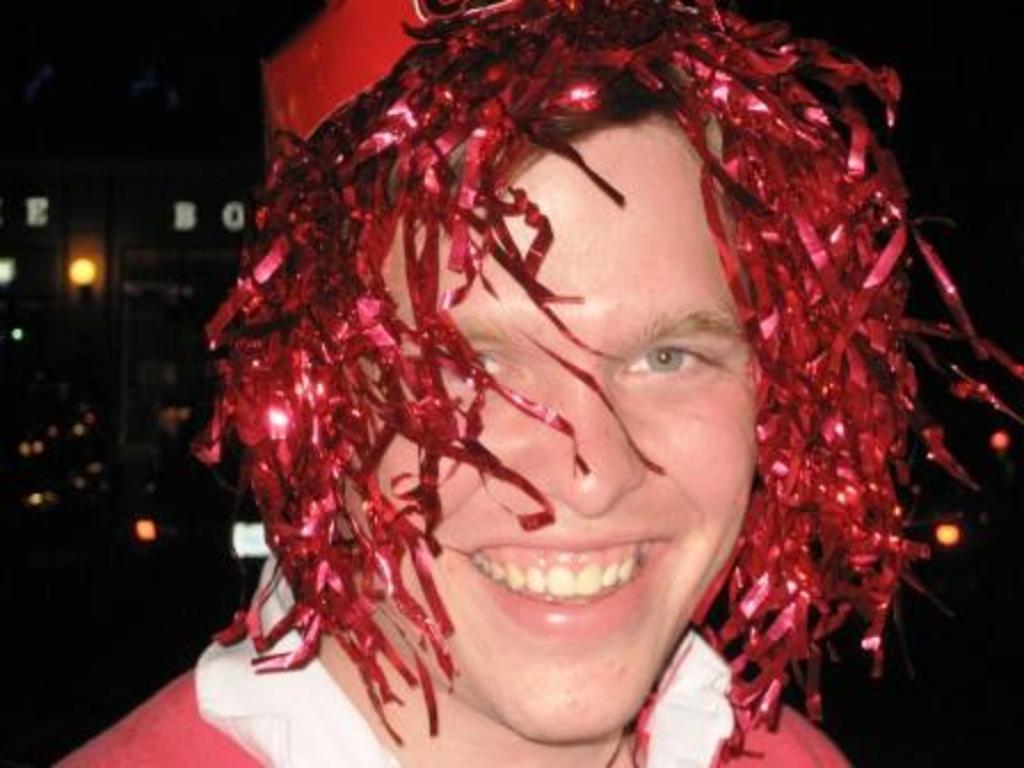Could you give a brief overview of what you see in this image? In this image I can see the person with the red and white color dress and also the head-wear. I can see the lights and there is a black background. 